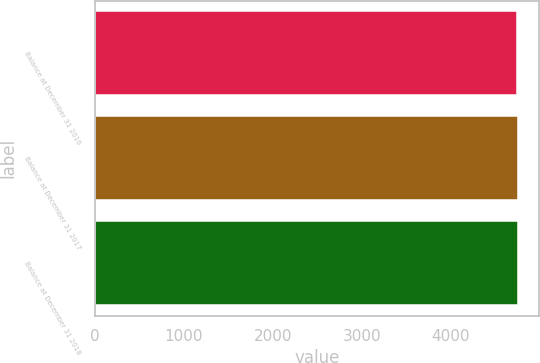Convert chart. <chart><loc_0><loc_0><loc_500><loc_500><bar_chart><fcel>Balance at December 31 2016<fcel>Balance at December 31 2017<fcel>Balance at December 31 2018<nl><fcel>4740<fcel>4751<fcel>4752.1<nl></chart> 